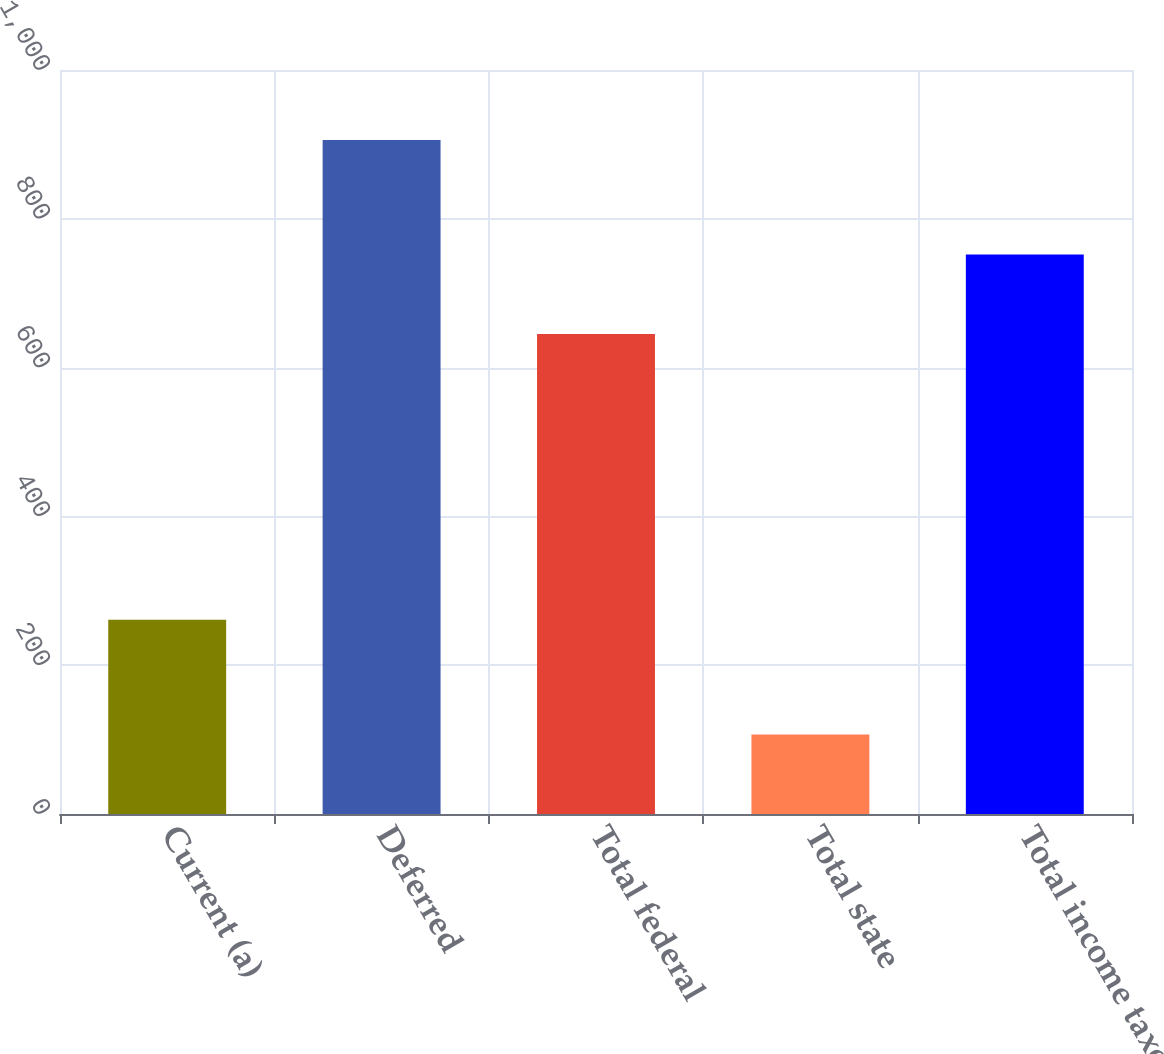Convert chart. <chart><loc_0><loc_0><loc_500><loc_500><bar_chart><fcel>Current (a)<fcel>Deferred<fcel>Total federal<fcel>Total state<fcel>Total income taxes<nl><fcel>261<fcel>906<fcel>645<fcel>107<fcel>752<nl></chart> 